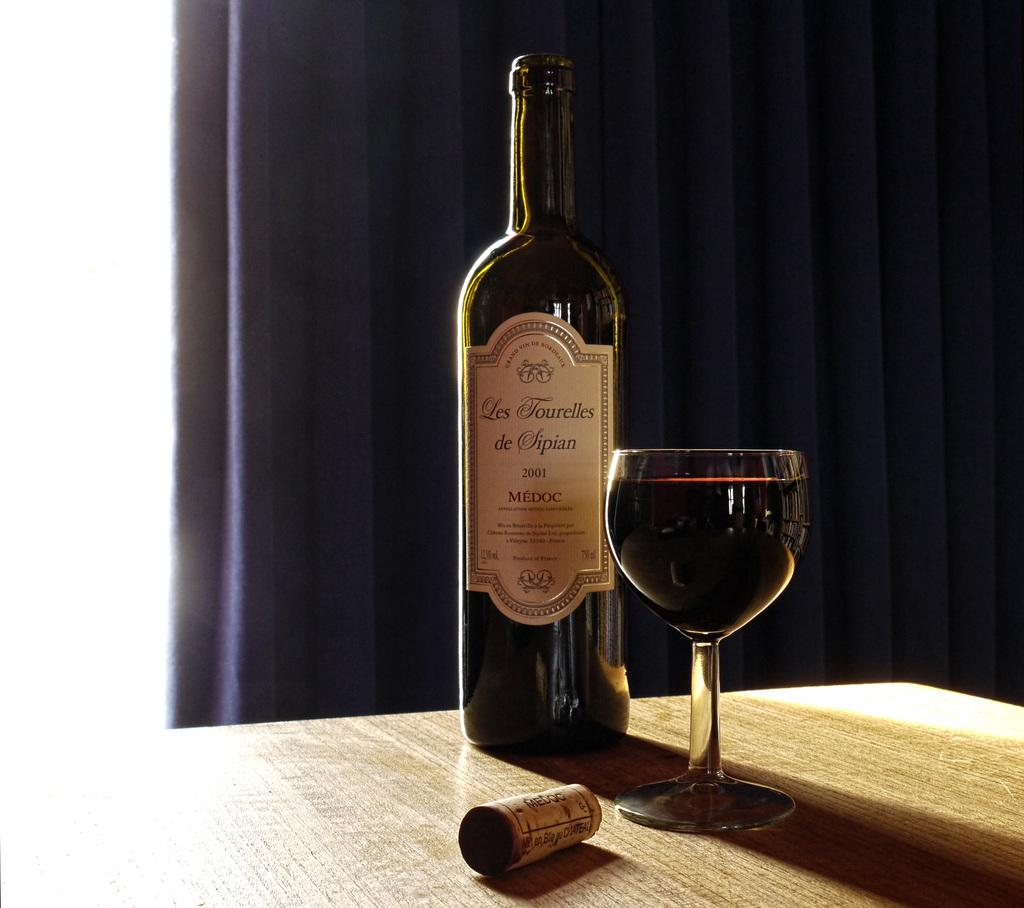<image>
Share a concise interpretation of the image provided. An open bottle of Les Tourelles sitting on a table next to a wineglass. 